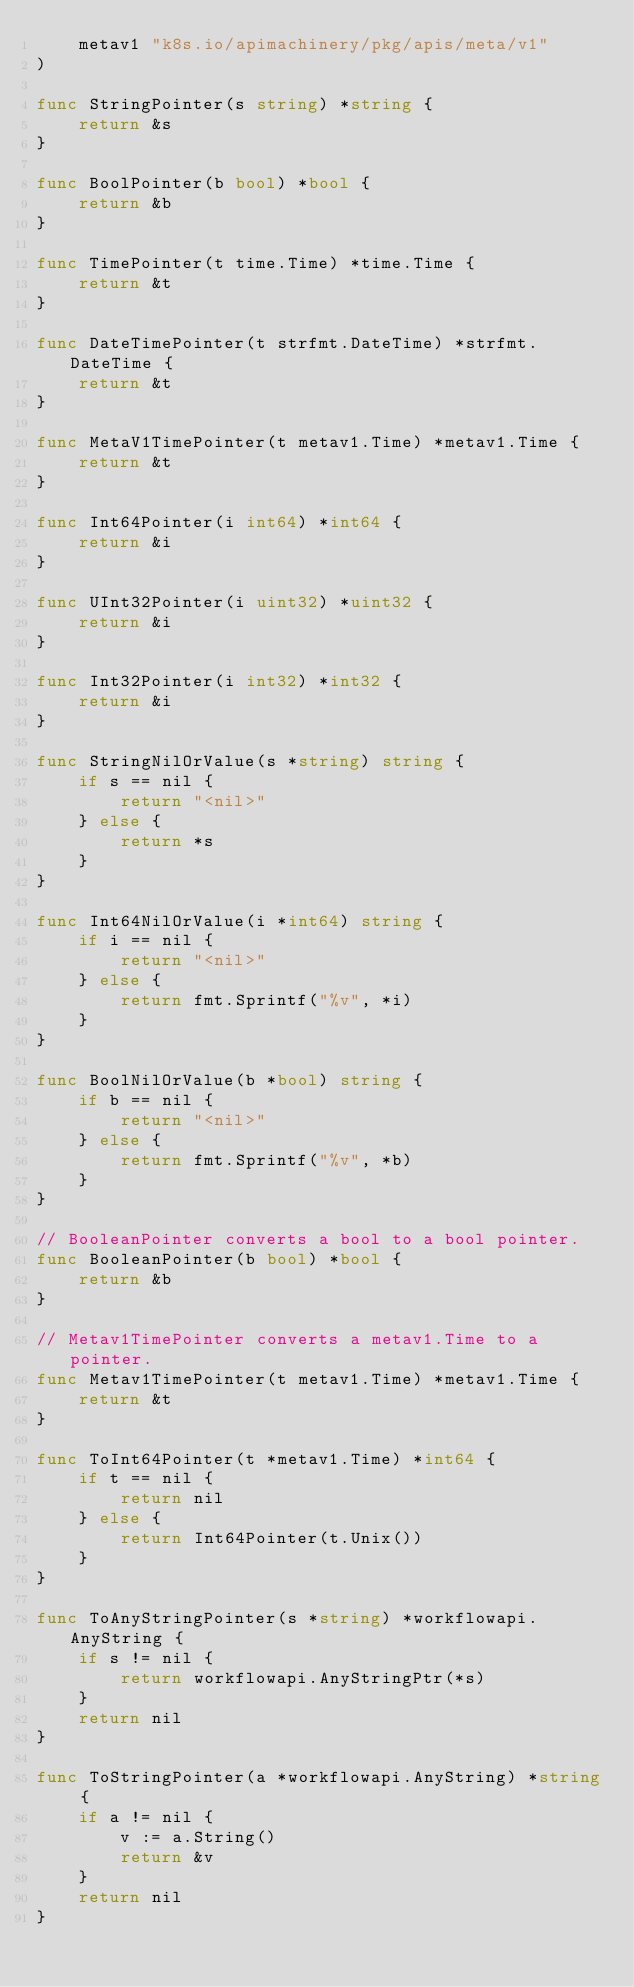<code> <loc_0><loc_0><loc_500><loc_500><_Go_>	metav1 "k8s.io/apimachinery/pkg/apis/meta/v1"
)

func StringPointer(s string) *string {
	return &s
}

func BoolPointer(b bool) *bool {
	return &b
}

func TimePointer(t time.Time) *time.Time {
	return &t
}

func DateTimePointer(t strfmt.DateTime) *strfmt.DateTime {
	return &t
}

func MetaV1TimePointer(t metav1.Time) *metav1.Time {
	return &t
}

func Int64Pointer(i int64) *int64 {
	return &i
}

func UInt32Pointer(i uint32) *uint32 {
	return &i
}

func Int32Pointer(i int32) *int32 {
	return &i
}

func StringNilOrValue(s *string) string {
	if s == nil {
		return "<nil>"
	} else {
		return *s
	}
}

func Int64NilOrValue(i *int64) string {
	if i == nil {
		return "<nil>"
	} else {
		return fmt.Sprintf("%v", *i)
	}
}

func BoolNilOrValue(b *bool) string {
	if b == nil {
		return "<nil>"
	} else {
		return fmt.Sprintf("%v", *b)
	}
}

// BooleanPointer converts a bool to a bool pointer.
func BooleanPointer(b bool) *bool {
	return &b
}

// Metav1TimePointer converts a metav1.Time to a pointer.
func Metav1TimePointer(t metav1.Time) *metav1.Time {
	return &t
}

func ToInt64Pointer(t *metav1.Time) *int64 {
	if t == nil {
		return nil
	} else {
		return Int64Pointer(t.Unix())
	}
}

func ToAnyStringPointer(s *string) *workflowapi.AnyString {
	if s != nil {
		return workflowapi.AnyStringPtr(*s)
	}
	return nil
}

func ToStringPointer(a *workflowapi.AnyString) *string {
	if a != nil {
		v := a.String()
		return &v
	}
	return nil
}
</code> 